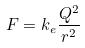<formula> <loc_0><loc_0><loc_500><loc_500>F = k _ { e } \frac { Q ^ { 2 } } { r ^ { 2 } }</formula> 